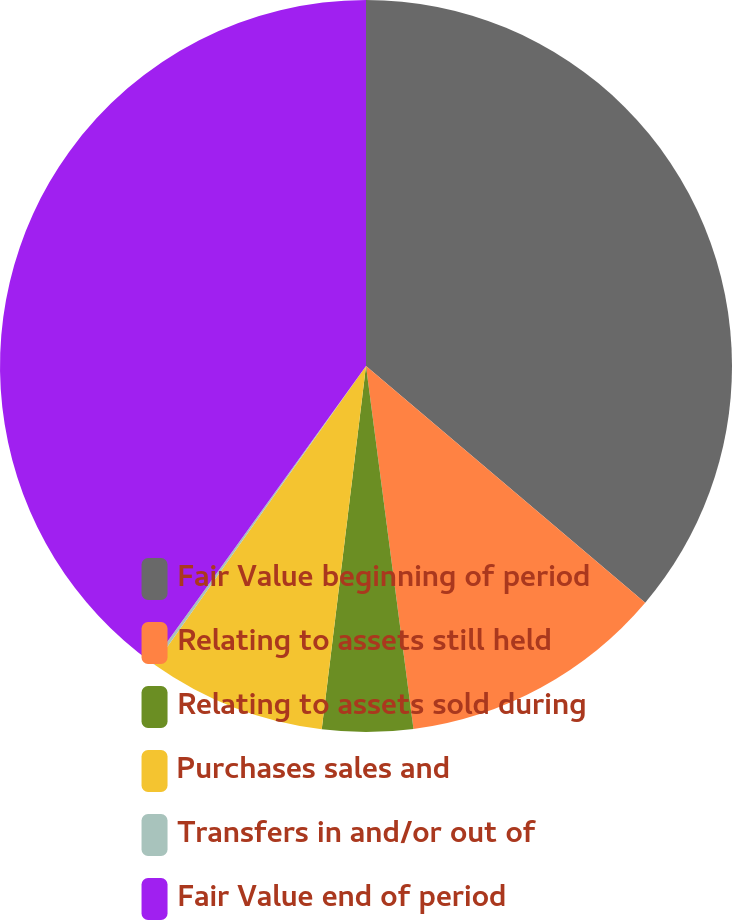<chart> <loc_0><loc_0><loc_500><loc_500><pie_chart><fcel>Fair Value beginning of period<fcel>Relating to assets still held<fcel>Relating to assets sold during<fcel>Purchases sales and<fcel>Transfers in and/or out of<fcel>Fair Value end of period<nl><fcel>36.19%<fcel>11.74%<fcel>4.0%<fcel>7.87%<fcel>0.14%<fcel>40.06%<nl></chart> 